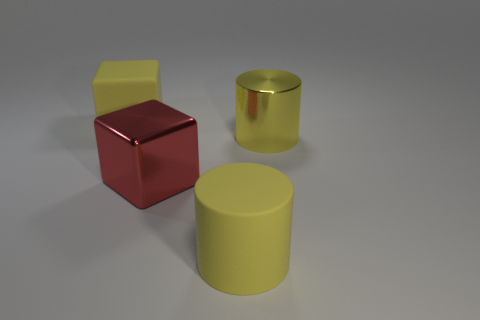Add 1 matte blocks. How many objects exist? 5 Subtract all large cyan rubber blocks. Subtract all big shiny things. How many objects are left? 2 Add 4 big yellow matte things. How many big yellow matte things are left? 6 Add 3 large yellow metallic cylinders. How many large yellow metallic cylinders exist? 4 Subtract 0 purple cylinders. How many objects are left? 4 